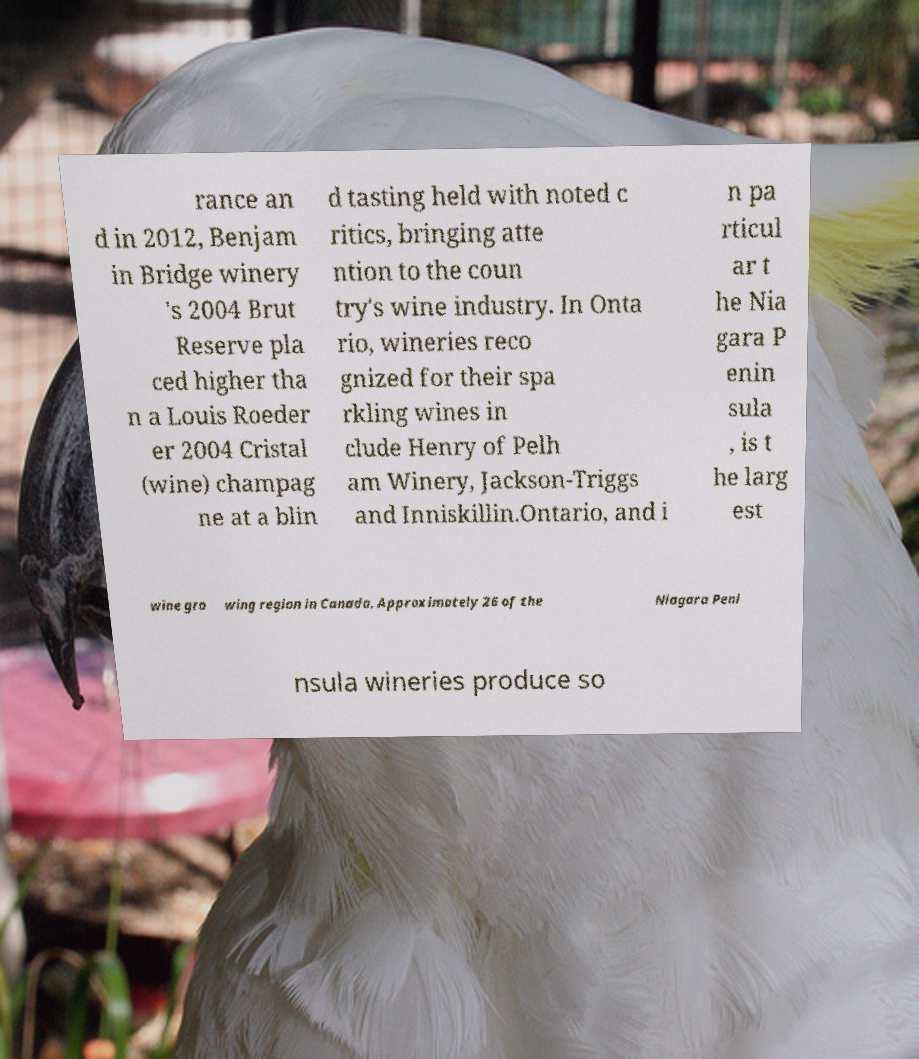Please read and relay the text visible in this image. What does it say? rance an d in 2012, Benjam in Bridge winery 's 2004 Brut Reserve pla ced higher tha n a Louis Roeder er 2004 Cristal (wine) champag ne at a blin d tasting held with noted c ritics, bringing atte ntion to the coun try's wine industry. In Onta rio, wineries reco gnized for their spa rkling wines in clude Henry of Pelh am Winery, Jackson-Triggs and Inniskillin.Ontario, and i n pa rticul ar t he Nia gara P enin sula , is t he larg est wine gro wing region in Canada. Approximately 26 of the Niagara Peni nsula wineries produce so 